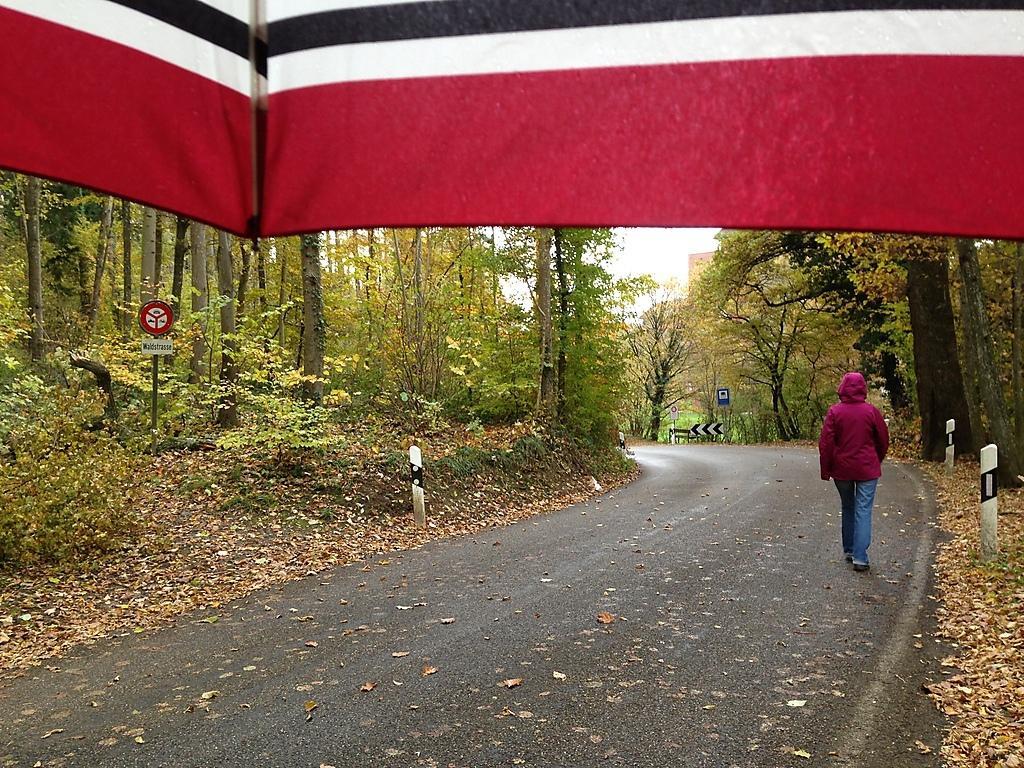In one or two sentences, can you explain what this image depicts? In the middle of the image a person is walking on the road. At the top of the image it looks like an umbrella. Behind the umbrella there are some trees, poles and sign boards. 